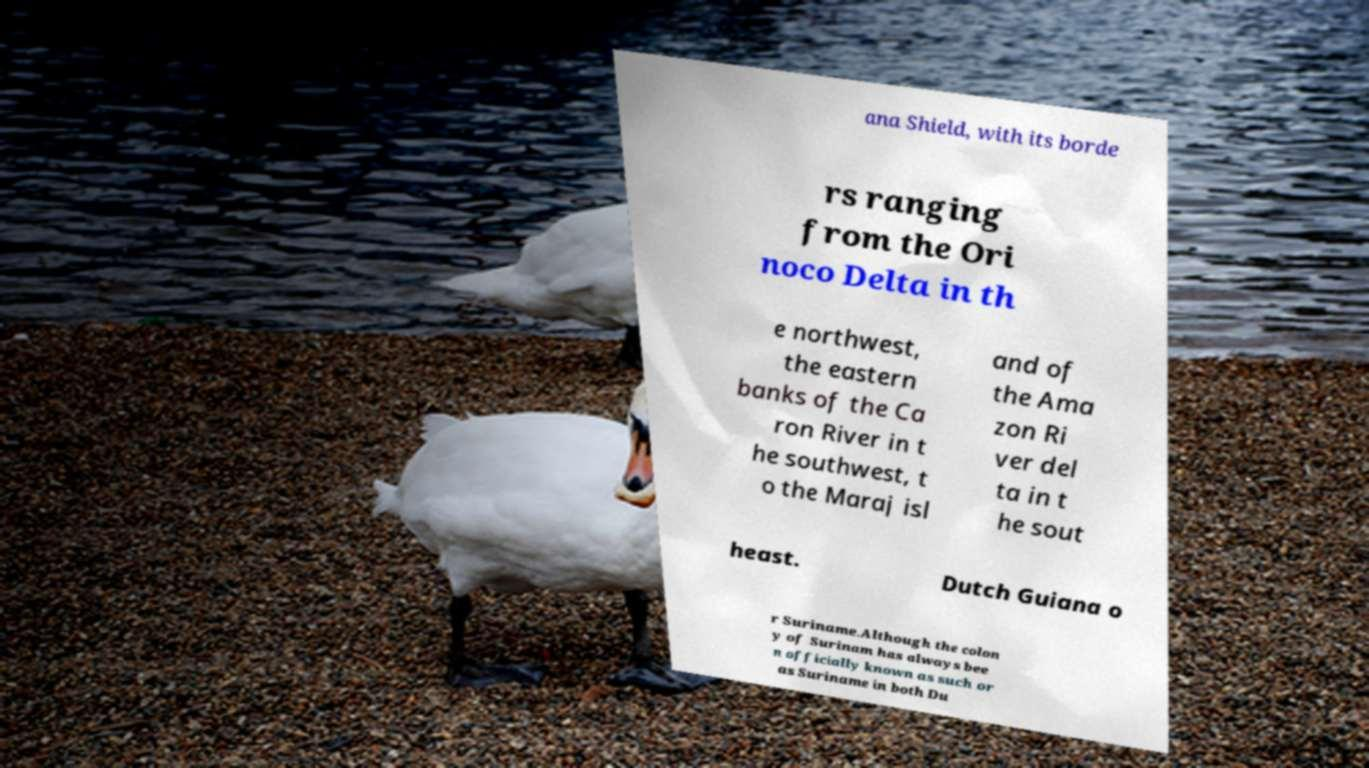Can you accurately transcribe the text from the provided image for me? ana Shield, with its borde rs ranging from the Ori noco Delta in th e northwest, the eastern banks of the Ca ron River in t he southwest, t o the Maraj isl and of the Ama zon Ri ver del ta in t he sout heast. Dutch Guiana o r Suriname.Although the colon y of Surinam has always bee n officially known as such or as Suriname in both Du 